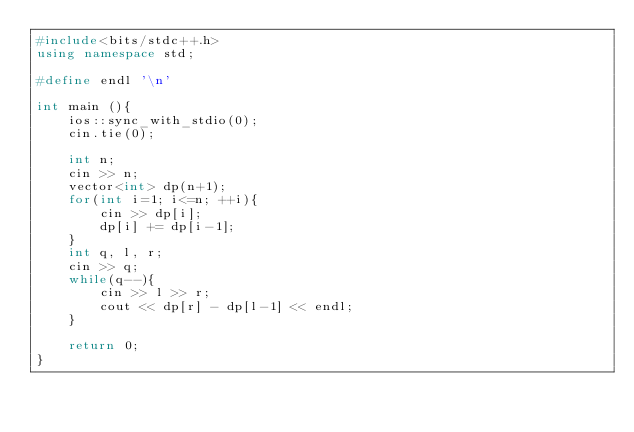<code> <loc_0><loc_0><loc_500><loc_500><_C++_>#include<bits/stdc++.h>
using namespace std;

#define endl '\n'

int main (){
	ios::sync_with_stdio(0);
	cin.tie(0);

	int n;
	cin >> n;
	vector<int> dp(n+1);
	for(int i=1; i<=n; ++i){
		cin >> dp[i];
		dp[i] += dp[i-1];
	}
	int q, l, r;
	cin >> q;
	while(q--){
		cin >> l >> r;
		cout << dp[r] - dp[l-1] << endl;
	}

	return 0;
}
</code> 